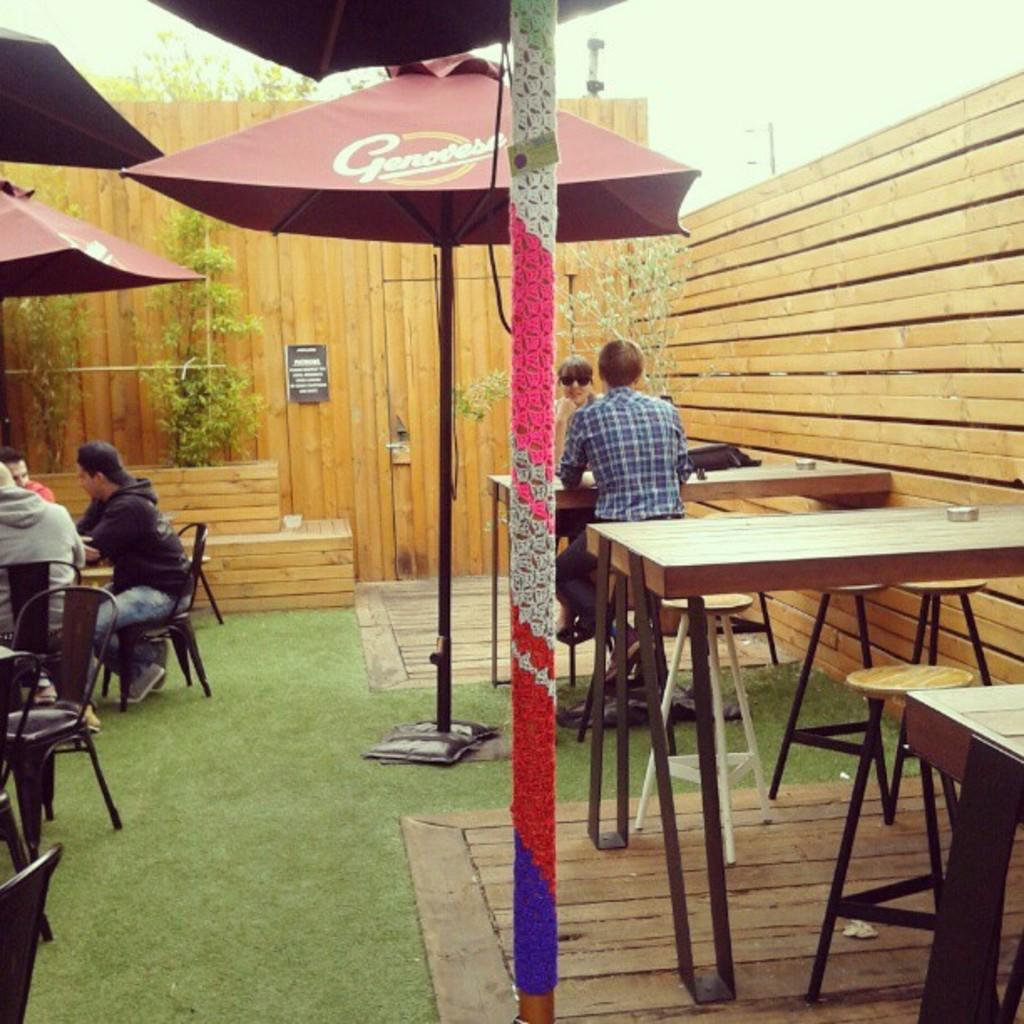What can be seen in the background of the image? The sky is visible in the image. What type of material is used for the wall in the image? There is a wooden wall in the image. What type of vegetation is present in the image? There is a plant and grass in the image. What type of furniture is visible in the image? There are chairs and tables in the image. Are there any people present in the image? Yes, there are people in the image. Where is the zebra located in the image? There is no zebra present in the image. What type of work is being done in the image? The image does not depict any work being done; it shows a scene with people, furniture, and vegetation. 